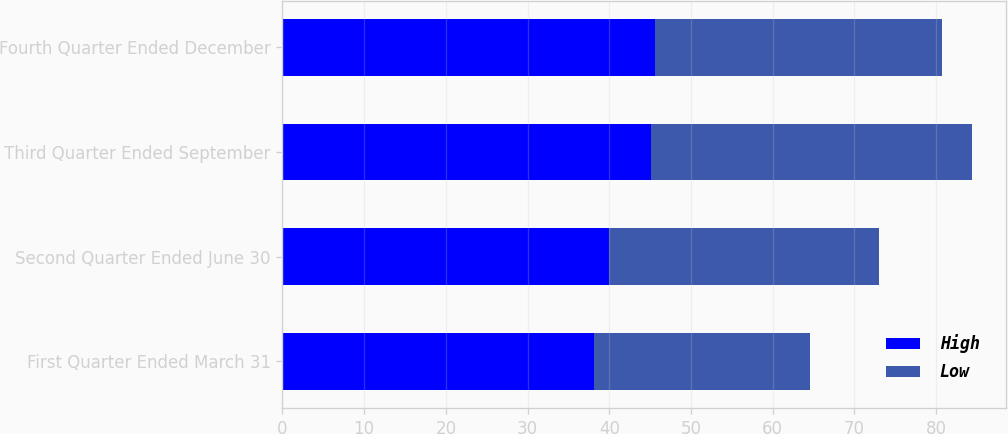Convert chart to OTSL. <chart><loc_0><loc_0><loc_500><loc_500><stacked_bar_chart><ecel><fcel>First Quarter Ended March 31<fcel>Second Quarter Ended June 30<fcel>Third Quarter Ended September<fcel>Fourth Quarter Ended December<nl><fcel>High<fcel>38.09<fcel>39.99<fcel>45.12<fcel>45.55<nl><fcel>Low<fcel>26.49<fcel>33.03<fcel>39.28<fcel>35.12<nl></chart> 